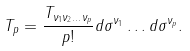<formula> <loc_0><loc_0><loc_500><loc_500>T _ { p } = \frac { T _ { \nu _ { 1 } \nu _ { 2 } \dots \nu _ { p } } } { p ! } d \sigma ^ { \nu _ { 1 } } \dots d \sigma ^ { \nu _ { p } } .</formula> 